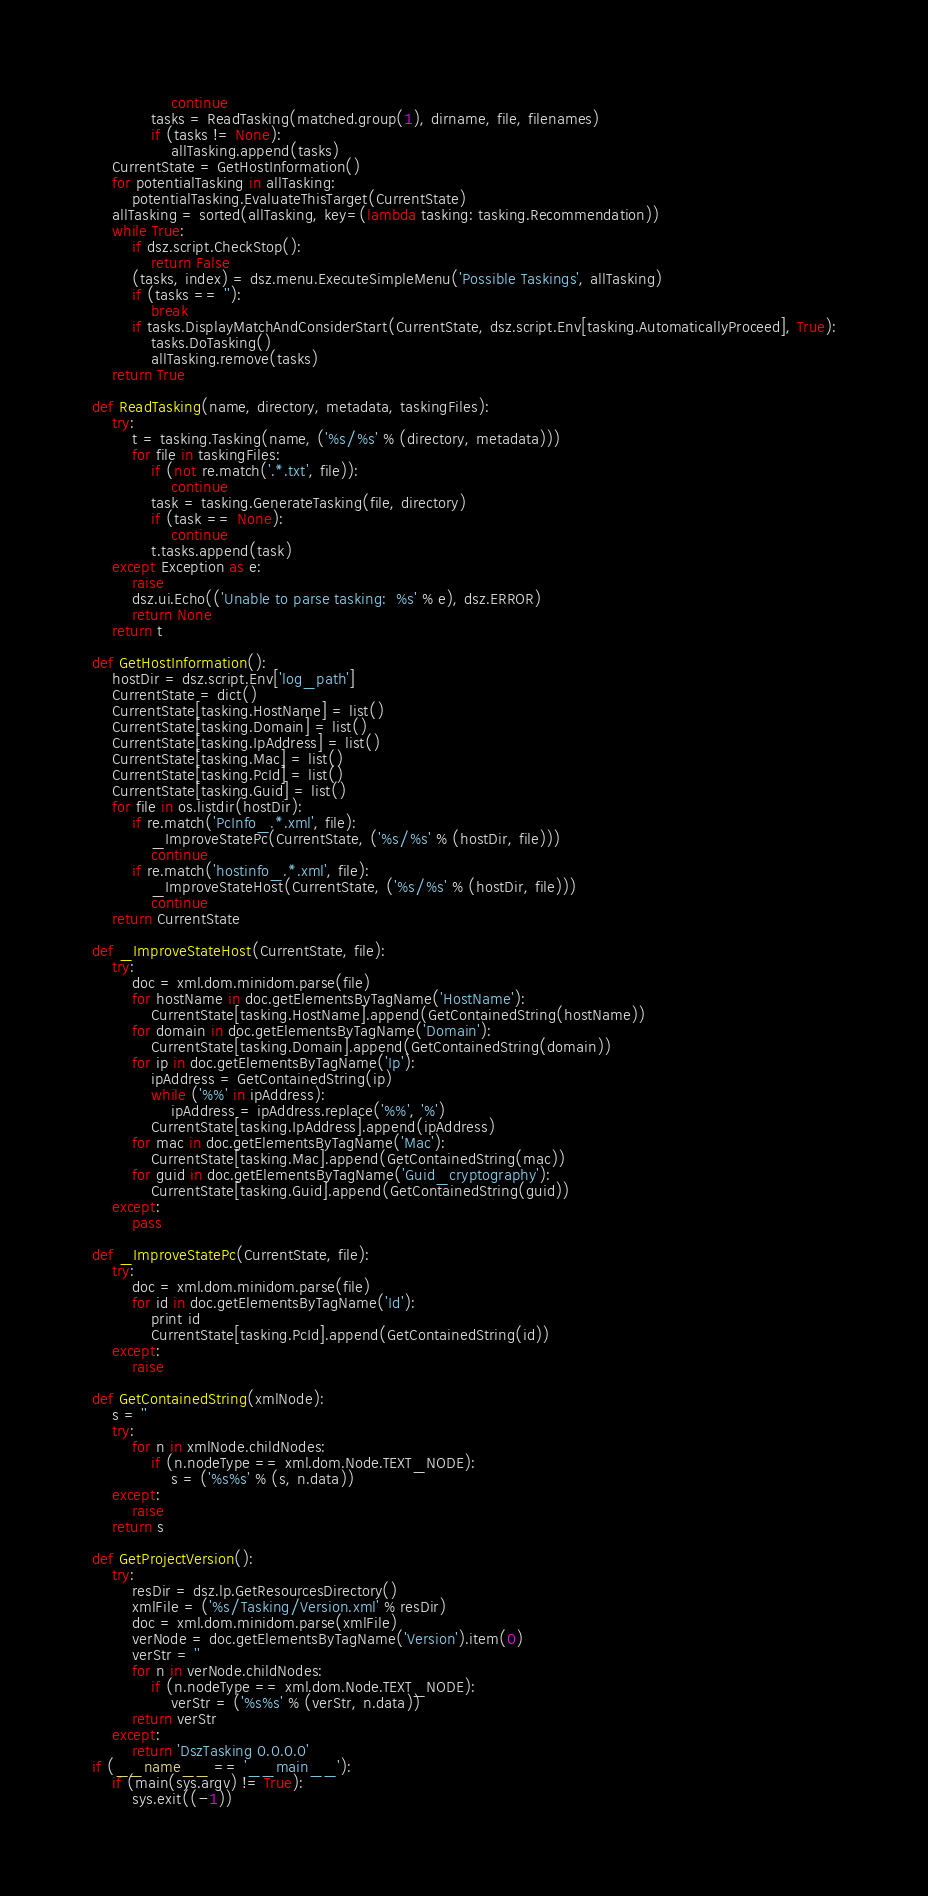<code> <loc_0><loc_0><loc_500><loc_500><_Python_>                continue
            tasks = ReadTasking(matched.group(1), dirname, file, filenames)
            if (tasks != None):
                allTasking.append(tasks)
    CurrentState = GetHostInformation()
    for potentialTasking in allTasking:
        potentialTasking.EvaluateThisTarget(CurrentState)
    allTasking = sorted(allTasking, key=(lambda tasking: tasking.Recommendation))
    while True:
        if dsz.script.CheckStop():
            return False
        (tasks, index) = dsz.menu.ExecuteSimpleMenu('Possible Taskings', allTasking)
        if (tasks == ''):
            break
        if tasks.DisplayMatchAndConsiderStart(CurrentState, dsz.script.Env[tasking.AutomaticallyProceed], True):
            tasks.DoTasking()
            allTasking.remove(tasks)
    return True

def ReadTasking(name, directory, metadata, taskingFiles):
    try:
        t = tasking.Tasking(name, ('%s/%s' % (directory, metadata)))
        for file in taskingFiles:
            if (not re.match('.*.txt', file)):
                continue
            task = tasking.GenerateTasking(file, directory)
            if (task == None):
                continue
            t.tasks.append(task)
    except Exception as e:
        raise 
        dsz.ui.Echo(('Unable to parse tasking:  %s' % e), dsz.ERROR)
        return None
    return t

def GetHostInformation():
    hostDir = dsz.script.Env['log_path']
    CurrentState = dict()
    CurrentState[tasking.HostName] = list()
    CurrentState[tasking.Domain] = list()
    CurrentState[tasking.IpAddress] = list()
    CurrentState[tasking.Mac] = list()
    CurrentState[tasking.PcId] = list()
    CurrentState[tasking.Guid] = list()
    for file in os.listdir(hostDir):
        if re.match('PcInfo_.*.xml', file):
            _ImproveStatePc(CurrentState, ('%s/%s' % (hostDir, file)))
            continue
        if re.match('hostinfo_.*.xml', file):
            _ImproveStateHost(CurrentState, ('%s/%s' % (hostDir, file)))
            continue
    return CurrentState

def _ImproveStateHost(CurrentState, file):
    try:
        doc = xml.dom.minidom.parse(file)
        for hostName in doc.getElementsByTagName('HostName'):
            CurrentState[tasking.HostName].append(GetContainedString(hostName))
        for domain in doc.getElementsByTagName('Domain'):
            CurrentState[tasking.Domain].append(GetContainedString(domain))
        for ip in doc.getElementsByTagName('Ip'):
            ipAddress = GetContainedString(ip)
            while ('%%' in ipAddress):
                ipAddress = ipAddress.replace('%%', '%')
            CurrentState[tasking.IpAddress].append(ipAddress)
        for mac in doc.getElementsByTagName('Mac'):
            CurrentState[tasking.Mac].append(GetContainedString(mac))
        for guid in doc.getElementsByTagName('Guid_cryptography'):
            CurrentState[tasking.Guid].append(GetContainedString(guid))
    except:
        pass

def _ImproveStatePc(CurrentState, file):
    try:
        doc = xml.dom.minidom.parse(file)
        for id in doc.getElementsByTagName('Id'):
            print id
            CurrentState[tasking.PcId].append(GetContainedString(id))
    except:
        raise 

def GetContainedString(xmlNode):
    s = ''
    try:
        for n in xmlNode.childNodes:
            if (n.nodeType == xml.dom.Node.TEXT_NODE):
                s = ('%s%s' % (s, n.data))
    except:
        raise 
    return s

def GetProjectVersion():
    try:
        resDir = dsz.lp.GetResourcesDirectory()
        xmlFile = ('%s/Tasking/Version.xml' % resDir)
        doc = xml.dom.minidom.parse(xmlFile)
        verNode = doc.getElementsByTagName('Version').item(0)
        verStr = ''
        for n in verNode.childNodes:
            if (n.nodeType == xml.dom.Node.TEXT_NODE):
                verStr = ('%s%s' % (verStr, n.data))
        return verStr
    except:
        return 'DszTasking 0.0.0.0'
if (__name__ == '__main__'):
    if (main(sys.argv) != True):
        sys.exit((-1))</code> 